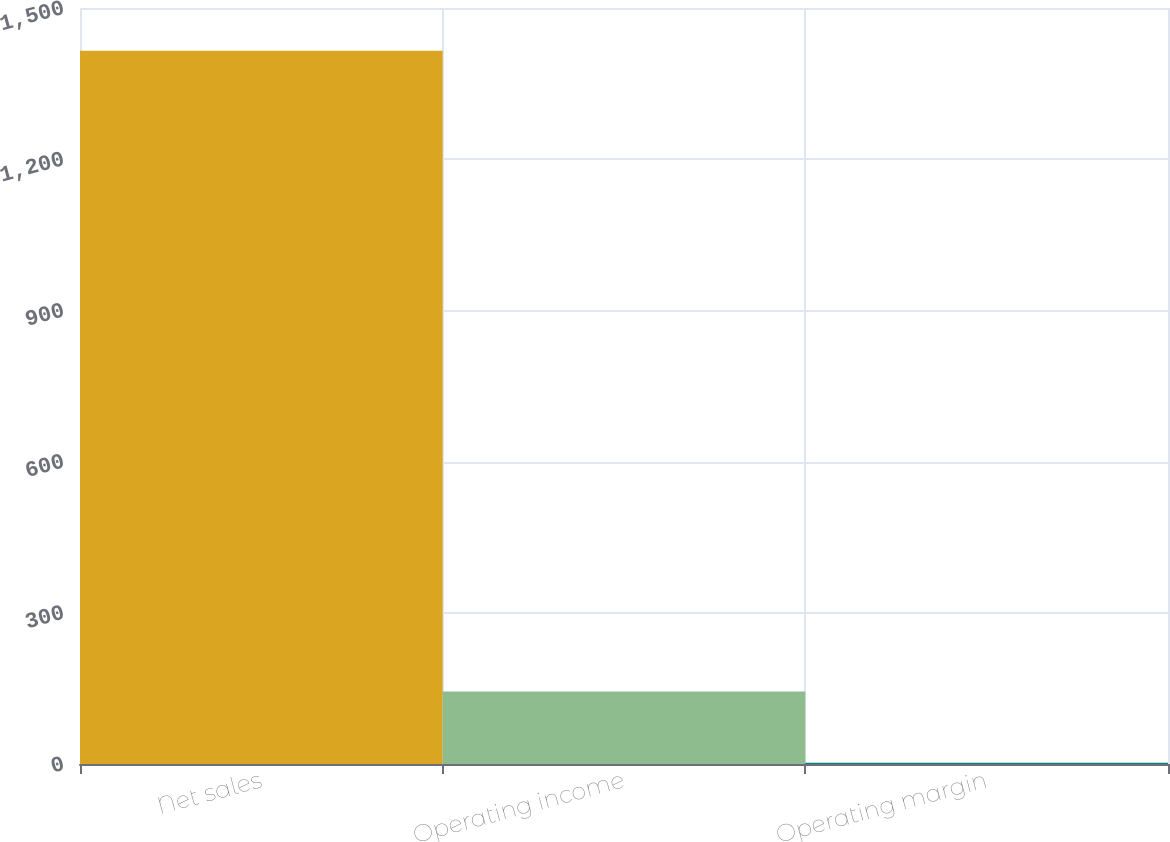Convert chart to OTSL. <chart><loc_0><loc_0><loc_500><loc_500><bar_chart><fcel>Net sales<fcel>Operating income<fcel>Operating margin<nl><fcel>1415<fcel>143.66<fcel>2.4<nl></chart> 